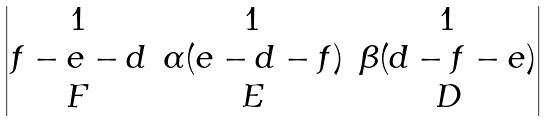<formula> <loc_0><loc_0><loc_500><loc_500>\begin{vmatrix} 1 & 1 & 1 \\ f - e - d & \alpha ( e - d - f ) & \beta ( d - f - e ) \\ F & E & D \end{vmatrix}</formula> 